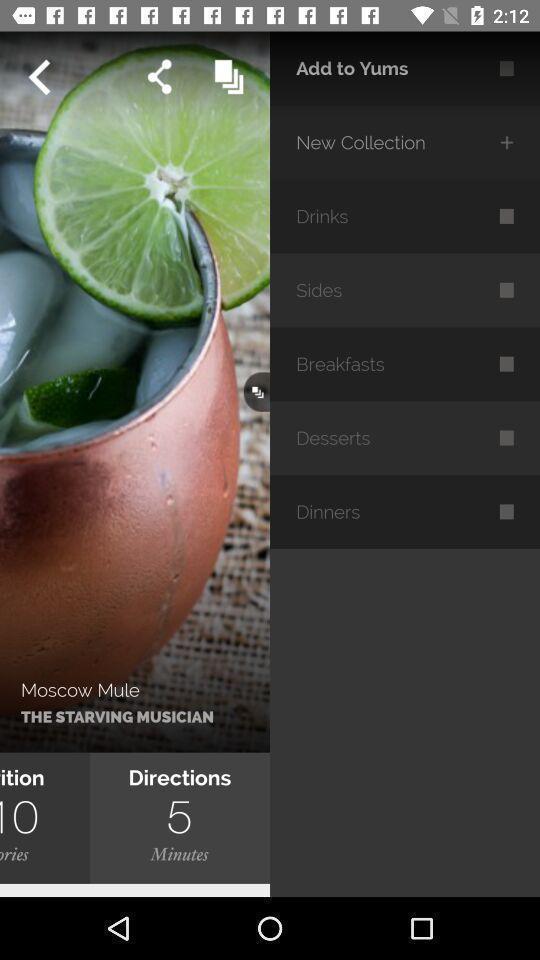Provide a detailed account of this screenshot. Screen displaying multiple food menu categories. 